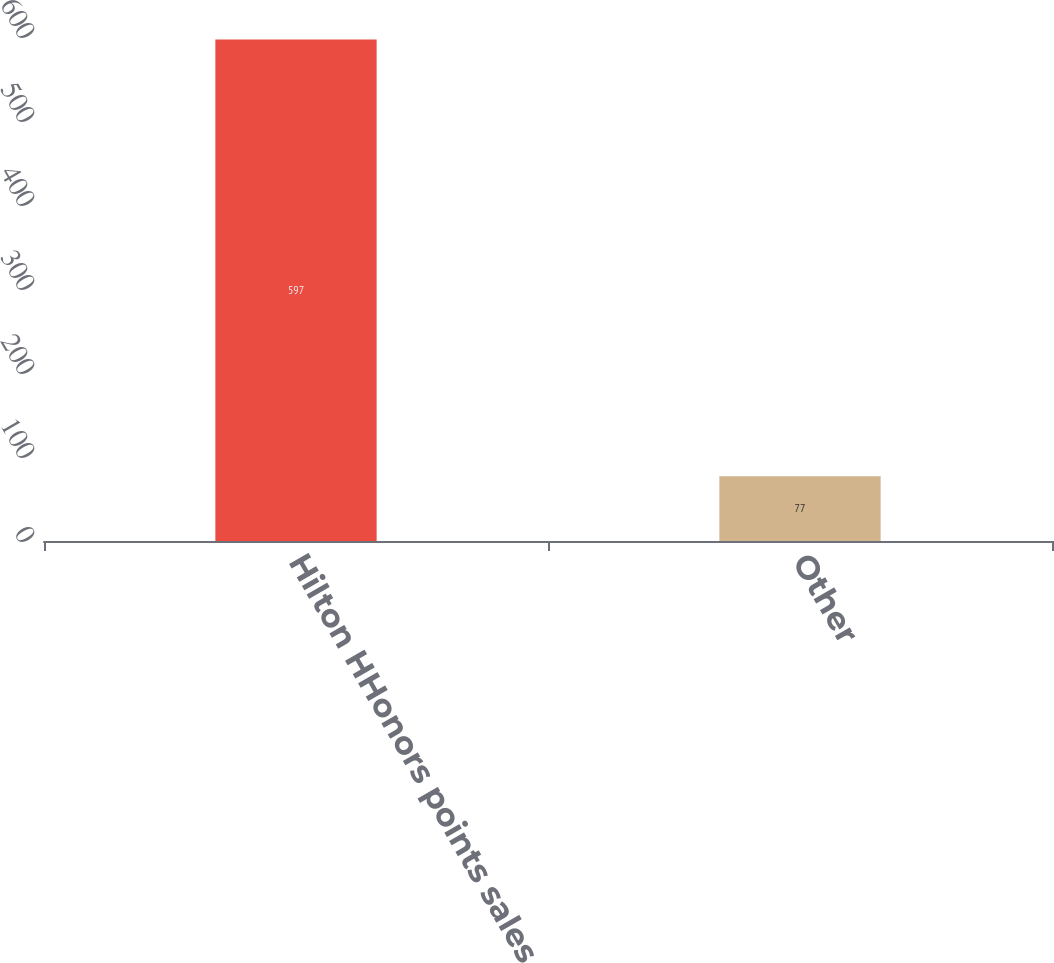Convert chart to OTSL. <chart><loc_0><loc_0><loc_500><loc_500><bar_chart><fcel>Hilton HHonors points sales<fcel>Other<nl><fcel>597<fcel>77<nl></chart> 